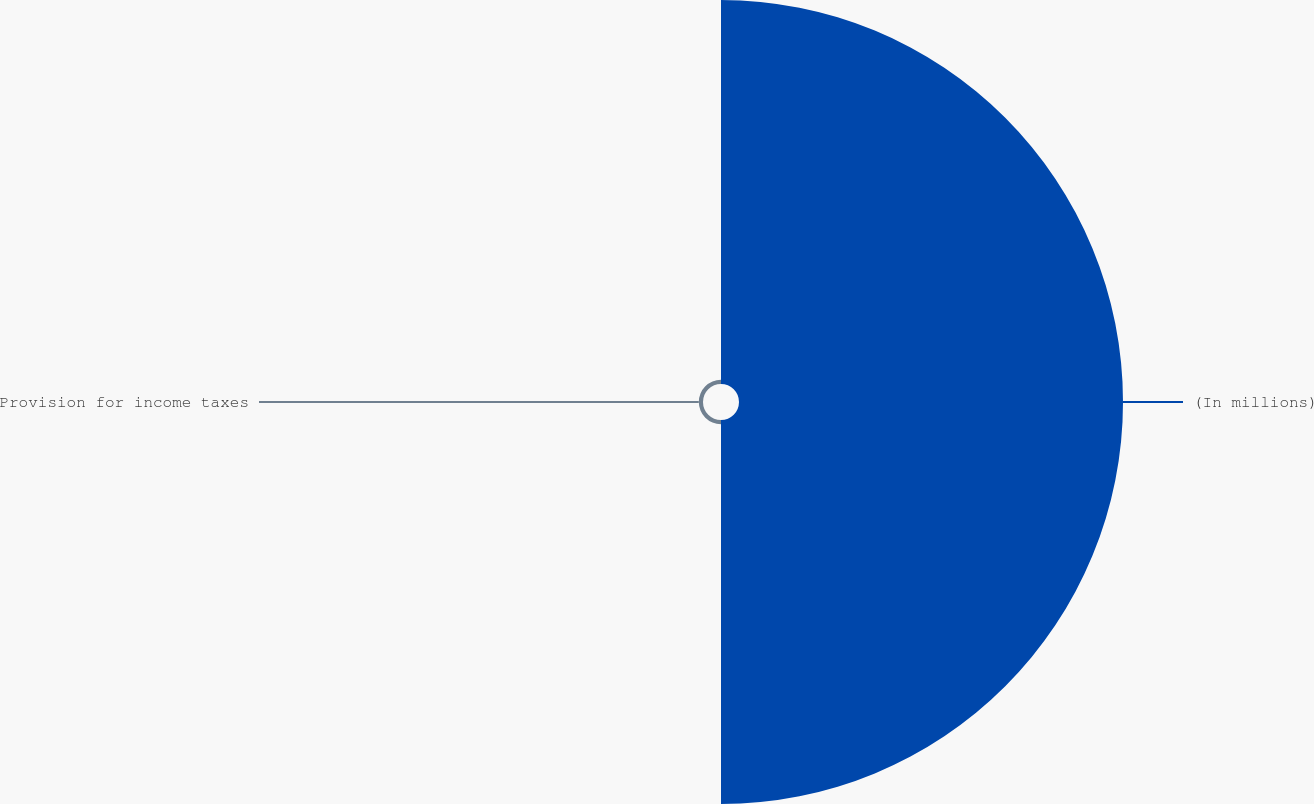<chart> <loc_0><loc_0><loc_500><loc_500><pie_chart><fcel>(In millions)<fcel>Provision for income taxes<nl><fcel>98.92%<fcel>1.08%<nl></chart> 